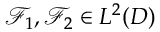<formula> <loc_0><loc_0><loc_500><loc_500>\mathcal { F } _ { 1 } , \mathcal { F } _ { 2 } \in L ^ { 2 } ( D )</formula> 